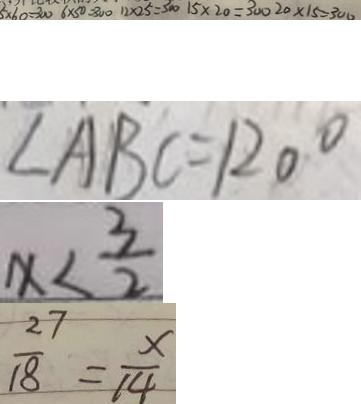Convert formula to latex. <formula><loc_0><loc_0><loc_500><loc_500>5 \times 6 0 = 3 0 0 6 \times 5 0 = 3 0 0 1 2 \times 2 5 = 3 0 0 1 5 \times 2 0 = 3 0 0 2 0 \times 1 5 = 3 0 0 
 \angle A B C = 1 2 0 ^ { \circ } 
 x < \frac { 3 } { 2 } 
 \frac { 2 7 } { 1 8 } = \frac { x } { 1 4 }</formula> 